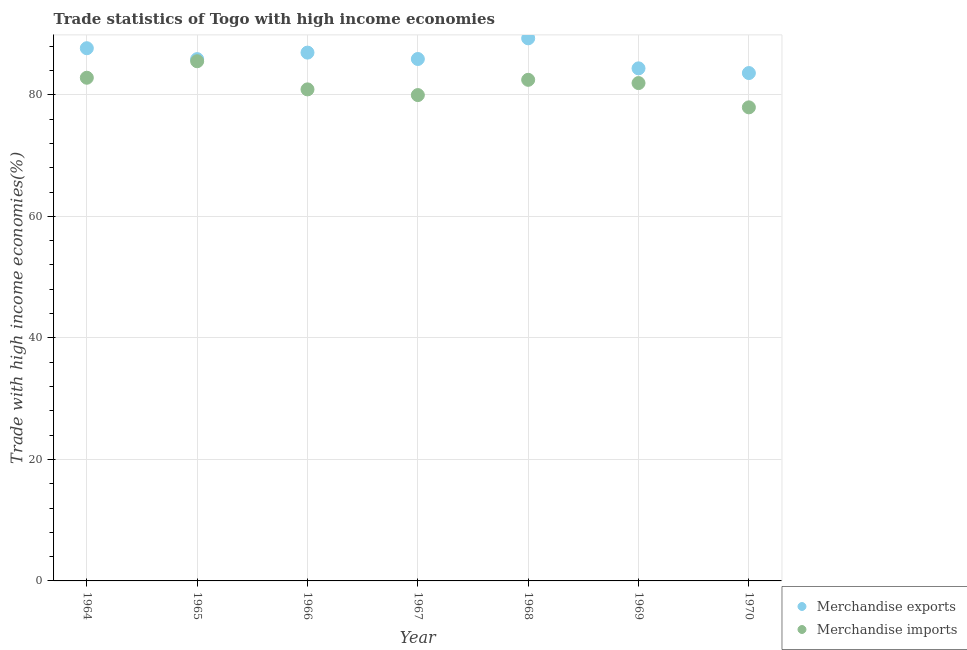Is the number of dotlines equal to the number of legend labels?
Offer a very short reply. Yes. What is the merchandise imports in 1964?
Provide a succinct answer. 82.81. Across all years, what is the maximum merchandise exports?
Offer a terse response. 89.3. Across all years, what is the minimum merchandise imports?
Give a very brief answer. 77.93. In which year was the merchandise exports maximum?
Provide a succinct answer. 1968. What is the total merchandise exports in the graph?
Your answer should be compact. 603.61. What is the difference between the merchandise exports in 1964 and that in 1968?
Ensure brevity in your answer.  -1.63. What is the difference between the merchandise imports in 1969 and the merchandise exports in 1965?
Give a very brief answer. -3.94. What is the average merchandise exports per year?
Offer a terse response. 86.23. In the year 1968, what is the difference between the merchandise imports and merchandise exports?
Your response must be concise. -6.83. What is the ratio of the merchandise exports in 1965 to that in 1968?
Ensure brevity in your answer.  0.96. Is the merchandise imports in 1964 less than that in 1965?
Give a very brief answer. Yes. What is the difference between the highest and the second highest merchandise exports?
Provide a succinct answer. 1.63. What is the difference between the highest and the lowest merchandise imports?
Offer a very short reply. 7.59. In how many years, is the merchandise exports greater than the average merchandise exports taken over all years?
Ensure brevity in your answer.  3. Is the sum of the merchandise imports in 1964 and 1968 greater than the maximum merchandise exports across all years?
Your answer should be very brief. Yes. Is the merchandise imports strictly greater than the merchandise exports over the years?
Your answer should be compact. No. Is the merchandise exports strictly less than the merchandise imports over the years?
Keep it short and to the point. No. How many dotlines are there?
Make the answer very short. 2. How many years are there in the graph?
Your answer should be compact. 7. Does the graph contain grids?
Ensure brevity in your answer.  Yes. Where does the legend appear in the graph?
Make the answer very short. Bottom right. How many legend labels are there?
Keep it short and to the point. 2. What is the title of the graph?
Your answer should be compact. Trade statistics of Togo with high income economies. What is the label or title of the X-axis?
Keep it short and to the point. Year. What is the label or title of the Y-axis?
Provide a short and direct response. Trade with high income economies(%). What is the Trade with high income economies(%) of Merchandise exports in 1964?
Offer a very short reply. 87.67. What is the Trade with high income economies(%) of Merchandise imports in 1964?
Your response must be concise. 82.81. What is the Trade with high income economies(%) in Merchandise exports in 1965?
Keep it short and to the point. 85.87. What is the Trade with high income economies(%) in Merchandise imports in 1965?
Your answer should be very brief. 85.52. What is the Trade with high income economies(%) in Merchandise exports in 1966?
Offer a very short reply. 86.94. What is the Trade with high income economies(%) of Merchandise imports in 1966?
Your response must be concise. 80.89. What is the Trade with high income economies(%) in Merchandise exports in 1967?
Provide a succinct answer. 85.89. What is the Trade with high income economies(%) in Merchandise imports in 1967?
Make the answer very short. 79.96. What is the Trade with high income economies(%) of Merchandise exports in 1968?
Ensure brevity in your answer.  89.3. What is the Trade with high income economies(%) in Merchandise imports in 1968?
Offer a terse response. 82.47. What is the Trade with high income economies(%) of Merchandise exports in 1969?
Provide a succinct answer. 84.35. What is the Trade with high income economies(%) in Merchandise imports in 1969?
Make the answer very short. 81.93. What is the Trade with high income economies(%) in Merchandise exports in 1970?
Provide a succinct answer. 83.58. What is the Trade with high income economies(%) in Merchandise imports in 1970?
Offer a terse response. 77.93. Across all years, what is the maximum Trade with high income economies(%) of Merchandise exports?
Your response must be concise. 89.3. Across all years, what is the maximum Trade with high income economies(%) of Merchandise imports?
Your answer should be very brief. 85.52. Across all years, what is the minimum Trade with high income economies(%) in Merchandise exports?
Your response must be concise. 83.58. Across all years, what is the minimum Trade with high income economies(%) of Merchandise imports?
Keep it short and to the point. 77.93. What is the total Trade with high income economies(%) in Merchandise exports in the graph?
Offer a terse response. 603.61. What is the total Trade with high income economies(%) of Merchandise imports in the graph?
Your answer should be compact. 571.51. What is the difference between the Trade with high income economies(%) in Merchandise exports in 1964 and that in 1965?
Your answer should be very brief. 1.79. What is the difference between the Trade with high income economies(%) in Merchandise imports in 1964 and that in 1965?
Provide a short and direct response. -2.71. What is the difference between the Trade with high income economies(%) in Merchandise exports in 1964 and that in 1966?
Provide a succinct answer. 0.72. What is the difference between the Trade with high income economies(%) of Merchandise imports in 1964 and that in 1966?
Your response must be concise. 1.92. What is the difference between the Trade with high income economies(%) in Merchandise exports in 1964 and that in 1967?
Keep it short and to the point. 1.77. What is the difference between the Trade with high income economies(%) of Merchandise imports in 1964 and that in 1967?
Offer a very short reply. 2.85. What is the difference between the Trade with high income economies(%) in Merchandise exports in 1964 and that in 1968?
Provide a short and direct response. -1.63. What is the difference between the Trade with high income economies(%) in Merchandise imports in 1964 and that in 1968?
Ensure brevity in your answer.  0.34. What is the difference between the Trade with high income economies(%) of Merchandise exports in 1964 and that in 1969?
Ensure brevity in your answer.  3.31. What is the difference between the Trade with high income economies(%) of Merchandise imports in 1964 and that in 1969?
Make the answer very short. 0.88. What is the difference between the Trade with high income economies(%) of Merchandise exports in 1964 and that in 1970?
Provide a short and direct response. 4.09. What is the difference between the Trade with high income economies(%) in Merchandise imports in 1964 and that in 1970?
Offer a very short reply. 4.87. What is the difference between the Trade with high income economies(%) of Merchandise exports in 1965 and that in 1966?
Provide a succinct answer. -1.07. What is the difference between the Trade with high income economies(%) of Merchandise imports in 1965 and that in 1966?
Offer a terse response. 4.63. What is the difference between the Trade with high income economies(%) of Merchandise exports in 1965 and that in 1967?
Make the answer very short. -0.02. What is the difference between the Trade with high income economies(%) of Merchandise imports in 1965 and that in 1967?
Provide a short and direct response. 5.57. What is the difference between the Trade with high income economies(%) of Merchandise exports in 1965 and that in 1968?
Keep it short and to the point. -3.42. What is the difference between the Trade with high income economies(%) of Merchandise imports in 1965 and that in 1968?
Provide a short and direct response. 3.06. What is the difference between the Trade with high income economies(%) of Merchandise exports in 1965 and that in 1969?
Provide a succinct answer. 1.52. What is the difference between the Trade with high income economies(%) in Merchandise imports in 1965 and that in 1969?
Your answer should be compact. 3.59. What is the difference between the Trade with high income economies(%) in Merchandise exports in 1965 and that in 1970?
Provide a short and direct response. 2.29. What is the difference between the Trade with high income economies(%) of Merchandise imports in 1965 and that in 1970?
Provide a short and direct response. 7.59. What is the difference between the Trade with high income economies(%) of Merchandise exports in 1966 and that in 1967?
Offer a terse response. 1.05. What is the difference between the Trade with high income economies(%) in Merchandise imports in 1966 and that in 1967?
Your answer should be compact. 0.94. What is the difference between the Trade with high income economies(%) in Merchandise exports in 1966 and that in 1968?
Your response must be concise. -2.35. What is the difference between the Trade with high income economies(%) in Merchandise imports in 1966 and that in 1968?
Your response must be concise. -1.58. What is the difference between the Trade with high income economies(%) of Merchandise exports in 1966 and that in 1969?
Your response must be concise. 2.59. What is the difference between the Trade with high income economies(%) of Merchandise imports in 1966 and that in 1969?
Provide a short and direct response. -1.04. What is the difference between the Trade with high income economies(%) in Merchandise exports in 1966 and that in 1970?
Your response must be concise. 3.36. What is the difference between the Trade with high income economies(%) in Merchandise imports in 1966 and that in 1970?
Make the answer very short. 2.96. What is the difference between the Trade with high income economies(%) in Merchandise exports in 1967 and that in 1968?
Give a very brief answer. -3.4. What is the difference between the Trade with high income economies(%) in Merchandise imports in 1967 and that in 1968?
Offer a very short reply. -2.51. What is the difference between the Trade with high income economies(%) of Merchandise exports in 1967 and that in 1969?
Your answer should be very brief. 1.54. What is the difference between the Trade with high income economies(%) in Merchandise imports in 1967 and that in 1969?
Offer a terse response. -1.98. What is the difference between the Trade with high income economies(%) in Merchandise exports in 1967 and that in 1970?
Provide a short and direct response. 2.31. What is the difference between the Trade with high income economies(%) of Merchandise imports in 1967 and that in 1970?
Your response must be concise. 2.02. What is the difference between the Trade with high income economies(%) of Merchandise exports in 1968 and that in 1969?
Your answer should be compact. 4.94. What is the difference between the Trade with high income economies(%) in Merchandise imports in 1968 and that in 1969?
Provide a short and direct response. 0.54. What is the difference between the Trade with high income economies(%) of Merchandise exports in 1968 and that in 1970?
Your answer should be very brief. 5.71. What is the difference between the Trade with high income economies(%) in Merchandise imports in 1968 and that in 1970?
Provide a short and direct response. 4.53. What is the difference between the Trade with high income economies(%) in Merchandise exports in 1969 and that in 1970?
Offer a very short reply. 0.77. What is the difference between the Trade with high income economies(%) in Merchandise imports in 1969 and that in 1970?
Make the answer very short. 4. What is the difference between the Trade with high income economies(%) in Merchandise exports in 1964 and the Trade with high income economies(%) in Merchandise imports in 1965?
Ensure brevity in your answer.  2.14. What is the difference between the Trade with high income economies(%) in Merchandise exports in 1964 and the Trade with high income economies(%) in Merchandise imports in 1966?
Keep it short and to the point. 6.77. What is the difference between the Trade with high income economies(%) in Merchandise exports in 1964 and the Trade with high income economies(%) in Merchandise imports in 1967?
Your answer should be very brief. 7.71. What is the difference between the Trade with high income economies(%) in Merchandise exports in 1964 and the Trade with high income economies(%) in Merchandise imports in 1968?
Offer a terse response. 5.2. What is the difference between the Trade with high income economies(%) of Merchandise exports in 1964 and the Trade with high income economies(%) of Merchandise imports in 1969?
Ensure brevity in your answer.  5.73. What is the difference between the Trade with high income economies(%) in Merchandise exports in 1964 and the Trade with high income economies(%) in Merchandise imports in 1970?
Your answer should be compact. 9.73. What is the difference between the Trade with high income economies(%) in Merchandise exports in 1965 and the Trade with high income economies(%) in Merchandise imports in 1966?
Your answer should be very brief. 4.98. What is the difference between the Trade with high income economies(%) of Merchandise exports in 1965 and the Trade with high income economies(%) of Merchandise imports in 1967?
Your response must be concise. 5.92. What is the difference between the Trade with high income economies(%) of Merchandise exports in 1965 and the Trade with high income economies(%) of Merchandise imports in 1968?
Ensure brevity in your answer.  3.41. What is the difference between the Trade with high income economies(%) in Merchandise exports in 1965 and the Trade with high income economies(%) in Merchandise imports in 1969?
Your answer should be very brief. 3.94. What is the difference between the Trade with high income economies(%) of Merchandise exports in 1965 and the Trade with high income economies(%) of Merchandise imports in 1970?
Make the answer very short. 7.94. What is the difference between the Trade with high income economies(%) of Merchandise exports in 1966 and the Trade with high income economies(%) of Merchandise imports in 1967?
Provide a succinct answer. 6.99. What is the difference between the Trade with high income economies(%) of Merchandise exports in 1966 and the Trade with high income economies(%) of Merchandise imports in 1968?
Provide a short and direct response. 4.48. What is the difference between the Trade with high income economies(%) of Merchandise exports in 1966 and the Trade with high income economies(%) of Merchandise imports in 1969?
Give a very brief answer. 5.01. What is the difference between the Trade with high income economies(%) of Merchandise exports in 1966 and the Trade with high income economies(%) of Merchandise imports in 1970?
Make the answer very short. 9.01. What is the difference between the Trade with high income economies(%) of Merchandise exports in 1967 and the Trade with high income economies(%) of Merchandise imports in 1968?
Your answer should be very brief. 3.43. What is the difference between the Trade with high income economies(%) of Merchandise exports in 1967 and the Trade with high income economies(%) of Merchandise imports in 1969?
Your answer should be very brief. 3.96. What is the difference between the Trade with high income economies(%) in Merchandise exports in 1967 and the Trade with high income economies(%) in Merchandise imports in 1970?
Keep it short and to the point. 7.96. What is the difference between the Trade with high income economies(%) in Merchandise exports in 1968 and the Trade with high income economies(%) in Merchandise imports in 1969?
Give a very brief answer. 7.36. What is the difference between the Trade with high income economies(%) in Merchandise exports in 1968 and the Trade with high income economies(%) in Merchandise imports in 1970?
Keep it short and to the point. 11.36. What is the difference between the Trade with high income economies(%) of Merchandise exports in 1969 and the Trade with high income economies(%) of Merchandise imports in 1970?
Your answer should be compact. 6.42. What is the average Trade with high income economies(%) in Merchandise exports per year?
Offer a very short reply. 86.23. What is the average Trade with high income economies(%) of Merchandise imports per year?
Offer a terse response. 81.64. In the year 1964, what is the difference between the Trade with high income economies(%) of Merchandise exports and Trade with high income economies(%) of Merchandise imports?
Your answer should be compact. 4.86. In the year 1965, what is the difference between the Trade with high income economies(%) of Merchandise exports and Trade with high income economies(%) of Merchandise imports?
Provide a succinct answer. 0.35. In the year 1966, what is the difference between the Trade with high income economies(%) in Merchandise exports and Trade with high income economies(%) in Merchandise imports?
Provide a succinct answer. 6.05. In the year 1967, what is the difference between the Trade with high income economies(%) of Merchandise exports and Trade with high income economies(%) of Merchandise imports?
Your answer should be very brief. 5.94. In the year 1968, what is the difference between the Trade with high income economies(%) of Merchandise exports and Trade with high income economies(%) of Merchandise imports?
Ensure brevity in your answer.  6.83. In the year 1969, what is the difference between the Trade with high income economies(%) of Merchandise exports and Trade with high income economies(%) of Merchandise imports?
Keep it short and to the point. 2.42. In the year 1970, what is the difference between the Trade with high income economies(%) of Merchandise exports and Trade with high income economies(%) of Merchandise imports?
Your answer should be very brief. 5.65. What is the ratio of the Trade with high income economies(%) in Merchandise exports in 1964 to that in 1965?
Your response must be concise. 1.02. What is the ratio of the Trade with high income economies(%) in Merchandise imports in 1964 to that in 1965?
Offer a terse response. 0.97. What is the ratio of the Trade with high income economies(%) in Merchandise exports in 1964 to that in 1966?
Your response must be concise. 1.01. What is the ratio of the Trade with high income economies(%) in Merchandise imports in 1964 to that in 1966?
Provide a succinct answer. 1.02. What is the ratio of the Trade with high income economies(%) of Merchandise exports in 1964 to that in 1967?
Ensure brevity in your answer.  1.02. What is the ratio of the Trade with high income economies(%) of Merchandise imports in 1964 to that in 1967?
Make the answer very short. 1.04. What is the ratio of the Trade with high income economies(%) of Merchandise exports in 1964 to that in 1968?
Provide a succinct answer. 0.98. What is the ratio of the Trade with high income economies(%) in Merchandise imports in 1964 to that in 1968?
Give a very brief answer. 1. What is the ratio of the Trade with high income economies(%) of Merchandise exports in 1964 to that in 1969?
Provide a short and direct response. 1.04. What is the ratio of the Trade with high income economies(%) of Merchandise imports in 1964 to that in 1969?
Ensure brevity in your answer.  1.01. What is the ratio of the Trade with high income economies(%) of Merchandise exports in 1964 to that in 1970?
Your answer should be very brief. 1.05. What is the ratio of the Trade with high income economies(%) in Merchandise imports in 1965 to that in 1966?
Keep it short and to the point. 1.06. What is the ratio of the Trade with high income economies(%) of Merchandise exports in 1965 to that in 1967?
Ensure brevity in your answer.  1. What is the ratio of the Trade with high income economies(%) in Merchandise imports in 1965 to that in 1967?
Provide a short and direct response. 1.07. What is the ratio of the Trade with high income economies(%) in Merchandise exports in 1965 to that in 1968?
Give a very brief answer. 0.96. What is the ratio of the Trade with high income economies(%) of Merchandise imports in 1965 to that in 1968?
Ensure brevity in your answer.  1.04. What is the ratio of the Trade with high income economies(%) of Merchandise imports in 1965 to that in 1969?
Offer a very short reply. 1.04. What is the ratio of the Trade with high income economies(%) in Merchandise exports in 1965 to that in 1970?
Offer a very short reply. 1.03. What is the ratio of the Trade with high income economies(%) of Merchandise imports in 1965 to that in 1970?
Give a very brief answer. 1.1. What is the ratio of the Trade with high income economies(%) of Merchandise exports in 1966 to that in 1967?
Your answer should be very brief. 1.01. What is the ratio of the Trade with high income economies(%) in Merchandise imports in 1966 to that in 1967?
Your response must be concise. 1.01. What is the ratio of the Trade with high income economies(%) in Merchandise exports in 1966 to that in 1968?
Your response must be concise. 0.97. What is the ratio of the Trade with high income economies(%) in Merchandise imports in 1966 to that in 1968?
Give a very brief answer. 0.98. What is the ratio of the Trade with high income economies(%) in Merchandise exports in 1966 to that in 1969?
Keep it short and to the point. 1.03. What is the ratio of the Trade with high income economies(%) in Merchandise imports in 1966 to that in 1969?
Your response must be concise. 0.99. What is the ratio of the Trade with high income economies(%) in Merchandise exports in 1966 to that in 1970?
Make the answer very short. 1.04. What is the ratio of the Trade with high income economies(%) in Merchandise imports in 1966 to that in 1970?
Your response must be concise. 1.04. What is the ratio of the Trade with high income economies(%) of Merchandise exports in 1967 to that in 1968?
Provide a short and direct response. 0.96. What is the ratio of the Trade with high income economies(%) of Merchandise imports in 1967 to that in 1968?
Give a very brief answer. 0.97. What is the ratio of the Trade with high income economies(%) in Merchandise exports in 1967 to that in 1969?
Give a very brief answer. 1.02. What is the ratio of the Trade with high income economies(%) of Merchandise imports in 1967 to that in 1969?
Provide a short and direct response. 0.98. What is the ratio of the Trade with high income economies(%) of Merchandise exports in 1967 to that in 1970?
Your answer should be very brief. 1.03. What is the ratio of the Trade with high income economies(%) of Merchandise imports in 1967 to that in 1970?
Offer a very short reply. 1.03. What is the ratio of the Trade with high income economies(%) of Merchandise exports in 1968 to that in 1969?
Provide a short and direct response. 1.06. What is the ratio of the Trade with high income economies(%) of Merchandise exports in 1968 to that in 1970?
Your response must be concise. 1.07. What is the ratio of the Trade with high income economies(%) in Merchandise imports in 1968 to that in 1970?
Offer a terse response. 1.06. What is the ratio of the Trade with high income economies(%) of Merchandise exports in 1969 to that in 1970?
Make the answer very short. 1.01. What is the ratio of the Trade with high income economies(%) in Merchandise imports in 1969 to that in 1970?
Ensure brevity in your answer.  1.05. What is the difference between the highest and the second highest Trade with high income economies(%) of Merchandise exports?
Provide a short and direct response. 1.63. What is the difference between the highest and the second highest Trade with high income economies(%) in Merchandise imports?
Your answer should be compact. 2.71. What is the difference between the highest and the lowest Trade with high income economies(%) in Merchandise exports?
Offer a terse response. 5.71. What is the difference between the highest and the lowest Trade with high income economies(%) of Merchandise imports?
Offer a terse response. 7.59. 